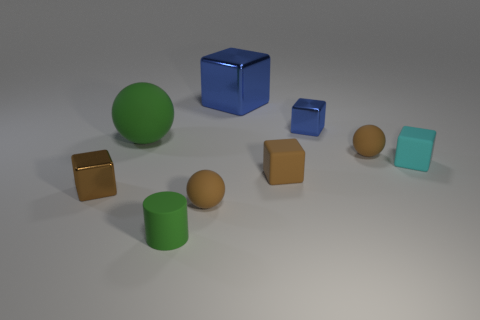Do the green cylinder that is in front of the large rubber ball and the big blue object have the same material?
Give a very brief answer. No. What is the material of the blue object that is the same size as the cyan rubber block?
Ensure brevity in your answer.  Metal. Are there more small brown things than small green things?
Provide a succinct answer. Yes. What number of objects are small brown cubes to the left of the tiny blue cube or rubber things?
Your answer should be compact. 7. Are there any cyan shiny balls that have the same size as the matte cylinder?
Your answer should be compact. No. Is the number of big blue metal blocks less than the number of shiny cylinders?
Give a very brief answer. No. How many cylinders are large red matte things or shiny things?
Ensure brevity in your answer.  0. How many small matte cylinders are the same color as the large rubber object?
Ensure brevity in your answer.  1. There is a matte object that is right of the small blue shiny object and on the left side of the small cyan rubber block; how big is it?
Provide a short and direct response. Small. Are there fewer matte cylinders right of the small rubber cylinder than tiny blue metallic things?
Offer a terse response. Yes. 